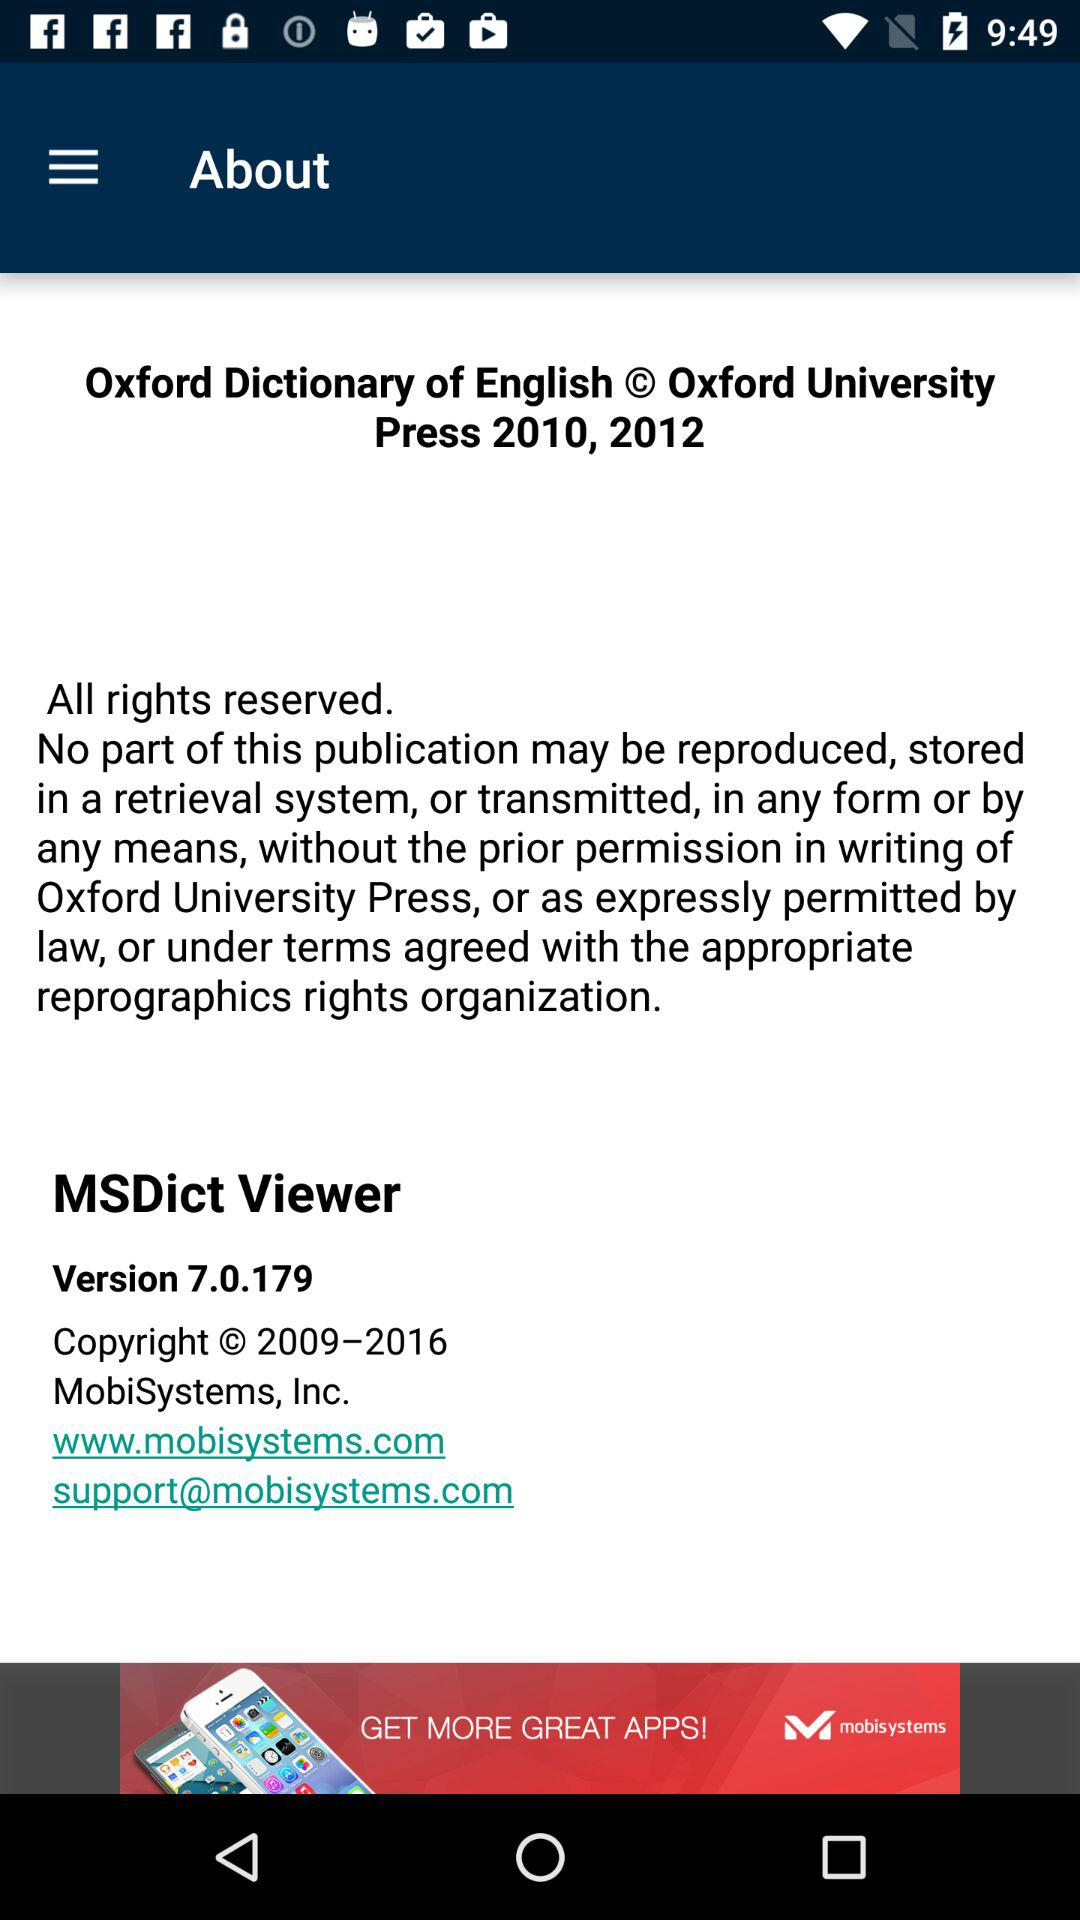What is the company's website? The website is www.mobisystems.com. 